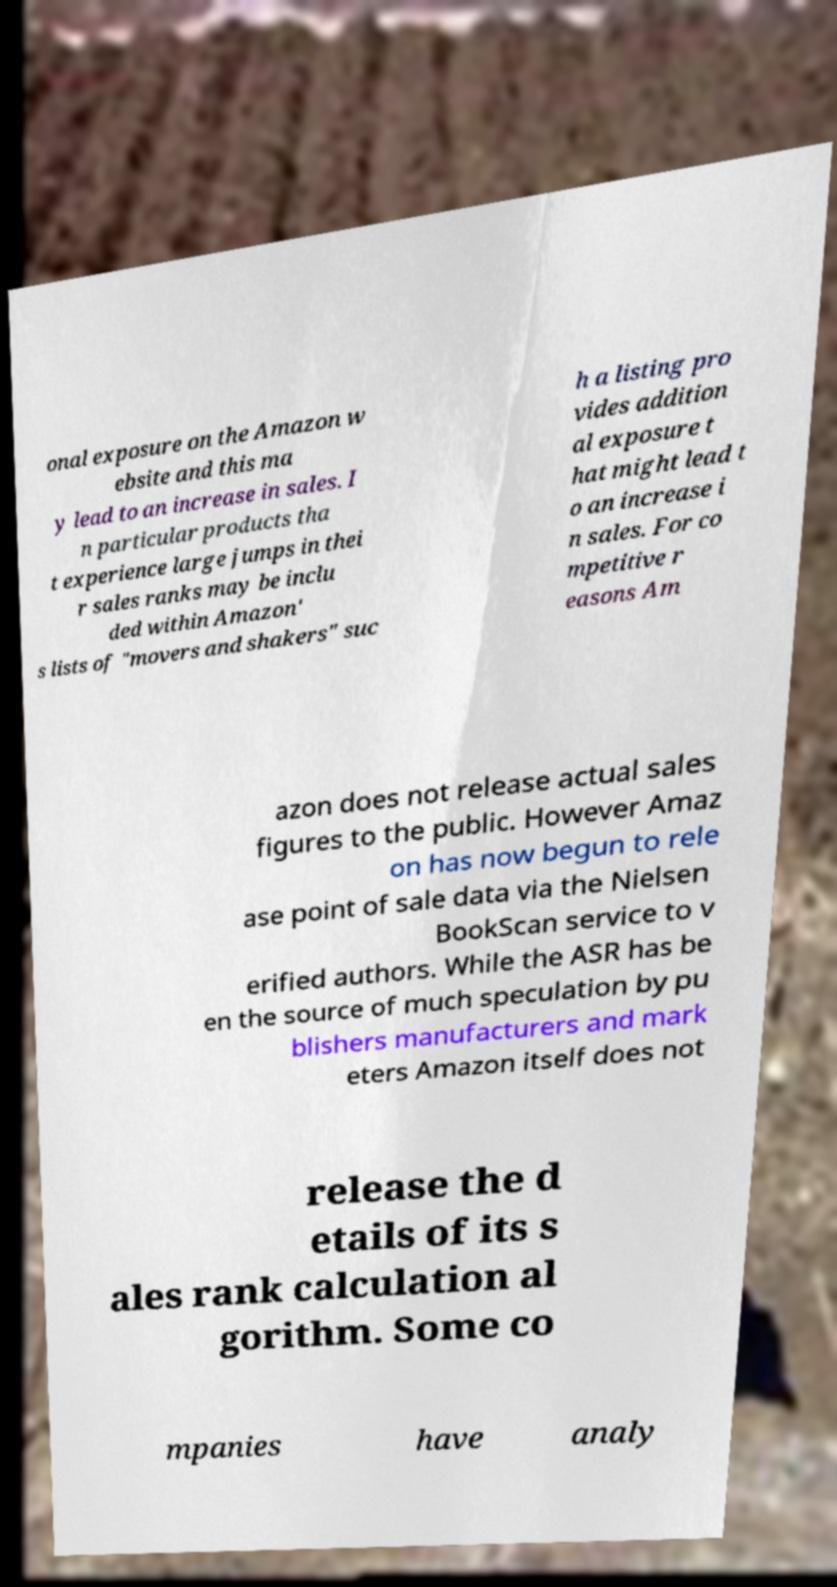What messages or text are displayed in this image? I need them in a readable, typed format. onal exposure on the Amazon w ebsite and this ma y lead to an increase in sales. I n particular products tha t experience large jumps in thei r sales ranks may be inclu ded within Amazon' s lists of "movers and shakers" suc h a listing pro vides addition al exposure t hat might lead t o an increase i n sales. For co mpetitive r easons Am azon does not release actual sales figures to the public. However Amaz on has now begun to rele ase point of sale data via the Nielsen BookScan service to v erified authors. While the ASR has be en the source of much speculation by pu blishers manufacturers and mark eters Amazon itself does not release the d etails of its s ales rank calculation al gorithm. Some co mpanies have analy 